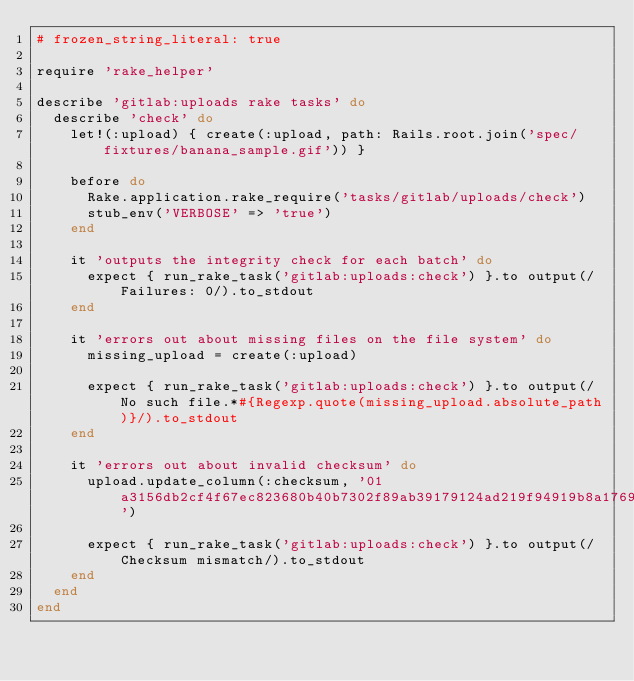Convert code to text. <code><loc_0><loc_0><loc_500><loc_500><_Ruby_># frozen_string_literal: true

require 'rake_helper'

describe 'gitlab:uploads rake tasks' do
  describe 'check' do
    let!(:upload) { create(:upload, path: Rails.root.join('spec/fixtures/banana_sample.gif')) }

    before do
      Rake.application.rake_require('tasks/gitlab/uploads/check')
      stub_env('VERBOSE' => 'true')
    end

    it 'outputs the integrity check for each batch' do
      expect { run_rake_task('gitlab:uploads:check') }.to output(/Failures: 0/).to_stdout
    end

    it 'errors out about missing files on the file system' do
      missing_upload = create(:upload)

      expect { run_rake_task('gitlab:uploads:check') }.to output(/No such file.*#{Regexp.quote(missing_upload.absolute_path)}/).to_stdout
    end

    it 'errors out about invalid checksum' do
      upload.update_column(:checksum, '01a3156db2cf4f67ec823680b40b7302f89ab39179124ad219f94919b8a1769e')

      expect { run_rake_task('gitlab:uploads:check') }.to output(/Checksum mismatch/).to_stdout
    end
  end
end
</code> 